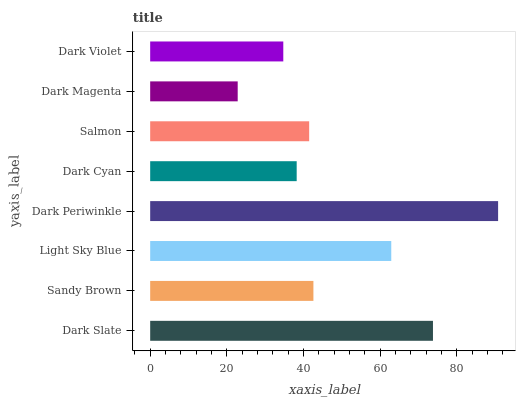Is Dark Magenta the minimum?
Answer yes or no. Yes. Is Dark Periwinkle the maximum?
Answer yes or no. Yes. Is Sandy Brown the minimum?
Answer yes or no. No. Is Sandy Brown the maximum?
Answer yes or no. No. Is Dark Slate greater than Sandy Brown?
Answer yes or no. Yes. Is Sandy Brown less than Dark Slate?
Answer yes or no. Yes. Is Sandy Brown greater than Dark Slate?
Answer yes or no. No. Is Dark Slate less than Sandy Brown?
Answer yes or no. No. Is Sandy Brown the high median?
Answer yes or no. Yes. Is Salmon the low median?
Answer yes or no. Yes. Is Dark Slate the high median?
Answer yes or no. No. Is Dark Magenta the low median?
Answer yes or no. No. 